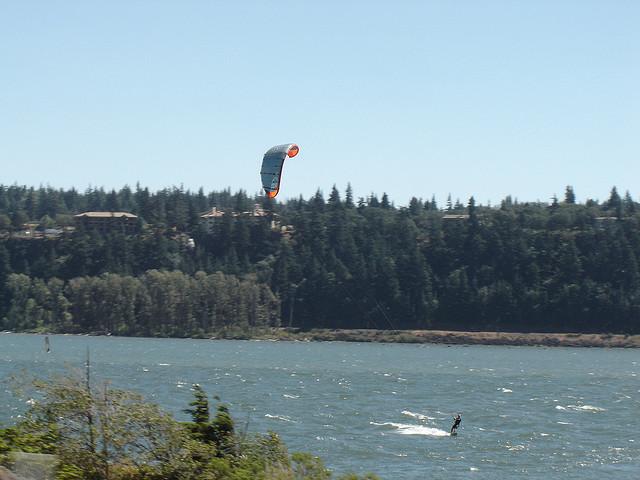Is the water calm?
Concise answer only. No. Are there any houses between the trees?
Short answer required. Yes. What sport is the guy participating in?
Short answer required. Parasailing. What is in the air?
Concise answer only. Kite. 